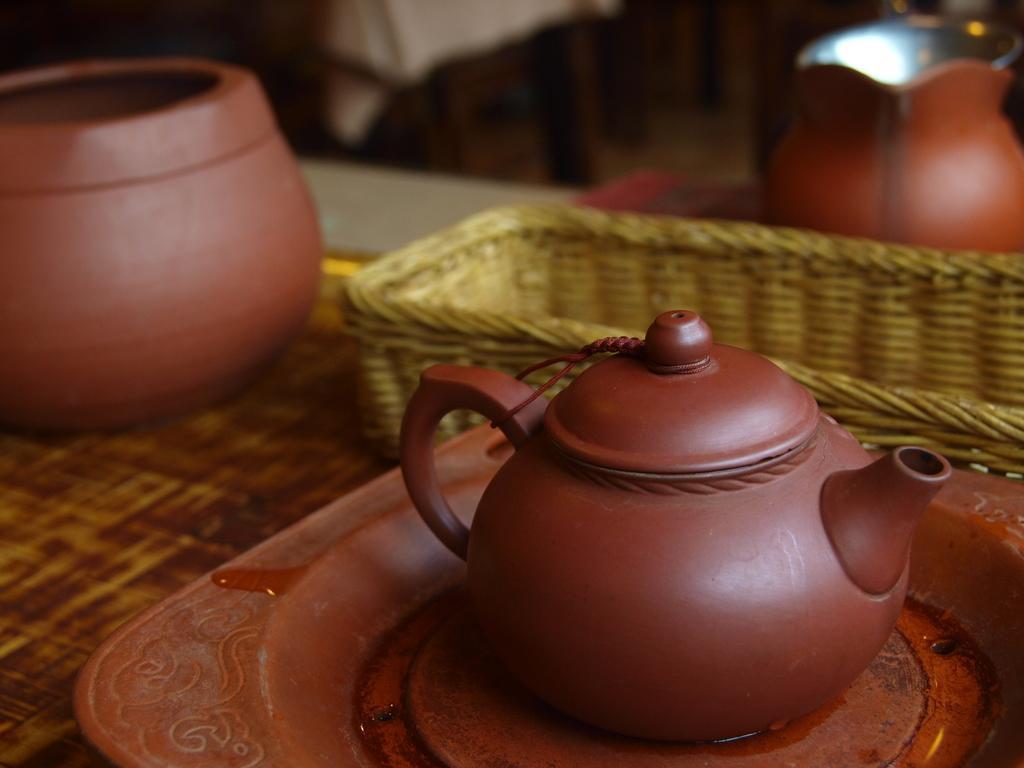Please provide a concise description of this image. In this image in the foreground there is one table, on the table there are some pots tray and one basket. In the background there are some other objects. 